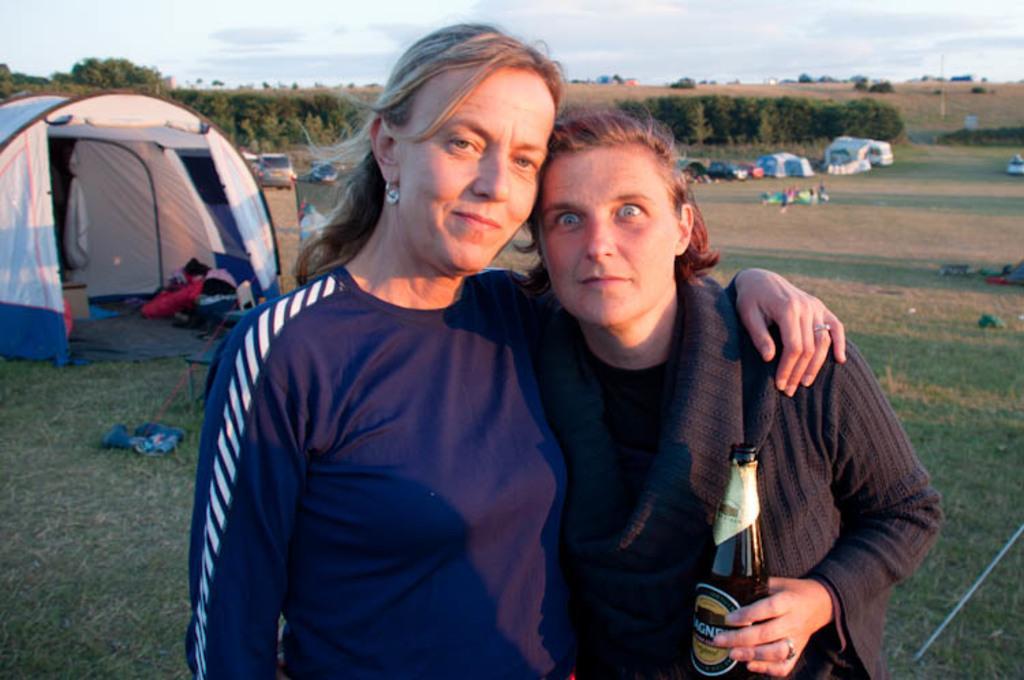Could you give a brief overview of what you see in this image? In this image I see 2 women standing and both of them are smiling, I can also see that this woman is holding a bottle. In the background I see lot of tents, vehicles and trees over here. 